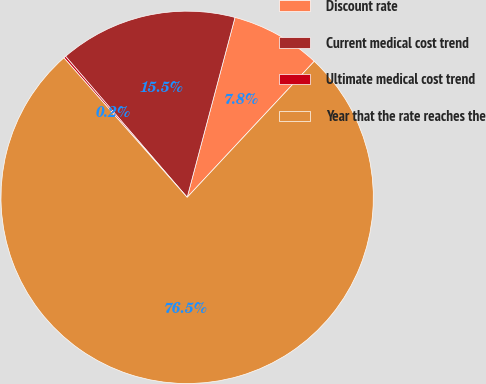Convert chart. <chart><loc_0><loc_0><loc_500><loc_500><pie_chart><fcel>Discount rate<fcel>Current medical cost trend<fcel>Ultimate medical cost trend<fcel>Year that the rate reaches the<nl><fcel>7.82%<fcel>15.46%<fcel>0.19%<fcel>76.53%<nl></chart> 